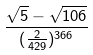<formula> <loc_0><loc_0><loc_500><loc_500>\frac { \sqrt { 5 } - \sqrt { 1 0 6 } } { ( \frac { 2 } { 4 2 9 } ) ^ { 3 6 6 } }</formula> 